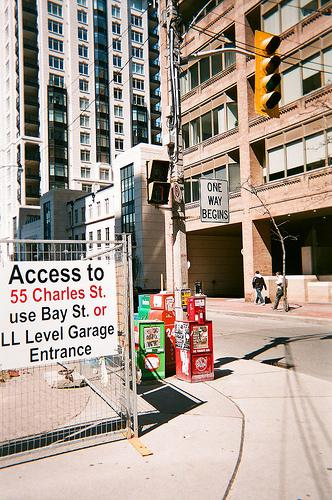Question: who is walking on the sidewalk?
Choices:
A. Two men.
B. Ten men.
C. Two women.
D. Three cats.
Answer with the letter. Answer: A Question: how many men are walking?
Choices:
A. Three.
B. Two.
C. Four.
D. Five.
Answer with the letter. Answer: B Question: when were the two men walking on the sidewalk?
Choices:
A. Yesterday.
B. Last night.
C. This morning.
D. Daytime.
Answer with the letter. Answer: D Question: what is on the fence?
Choices:
A. A bird.
B. A sign.
C. A scarecrow.
D. A lock.
Answer with the letter. Answer: B Question: why are there traffic lights?
Choices:
A. To prevent accidents.
B. To control traffic.
C. To provide direction.
D. To caution drivers.
Answer with the letter. Answer: A Question: what does sign above the street say?
Choices:
A. No left turn.
B. No right turn.
C. Yield.
D. One way begins.
Answer with the letter. Answer: D 